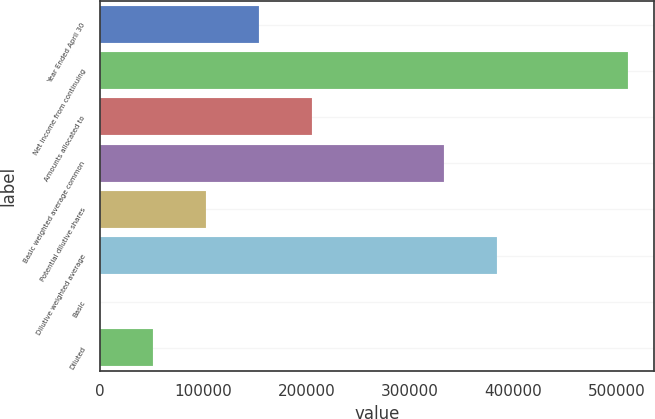Convert chart to OTSL. <chart><loc_0><loc_0><loc_500><loc_500><bar_chart><fcel>Year Ended April 30<fcel>Net income from continuing<fcel>Amounts allocated to<fcel>Basic weighted average common<fcel>Potential dilutive shares<fcel>Dilutive weighted average<fcel>Basic<fcel>Diluted<nl><fcel>153918<fcel>511013<fcel>205223<fcel>332787<fcel>102612<fcel>384092<fcel>1.53<fcel>51306.9<nl></chart> 